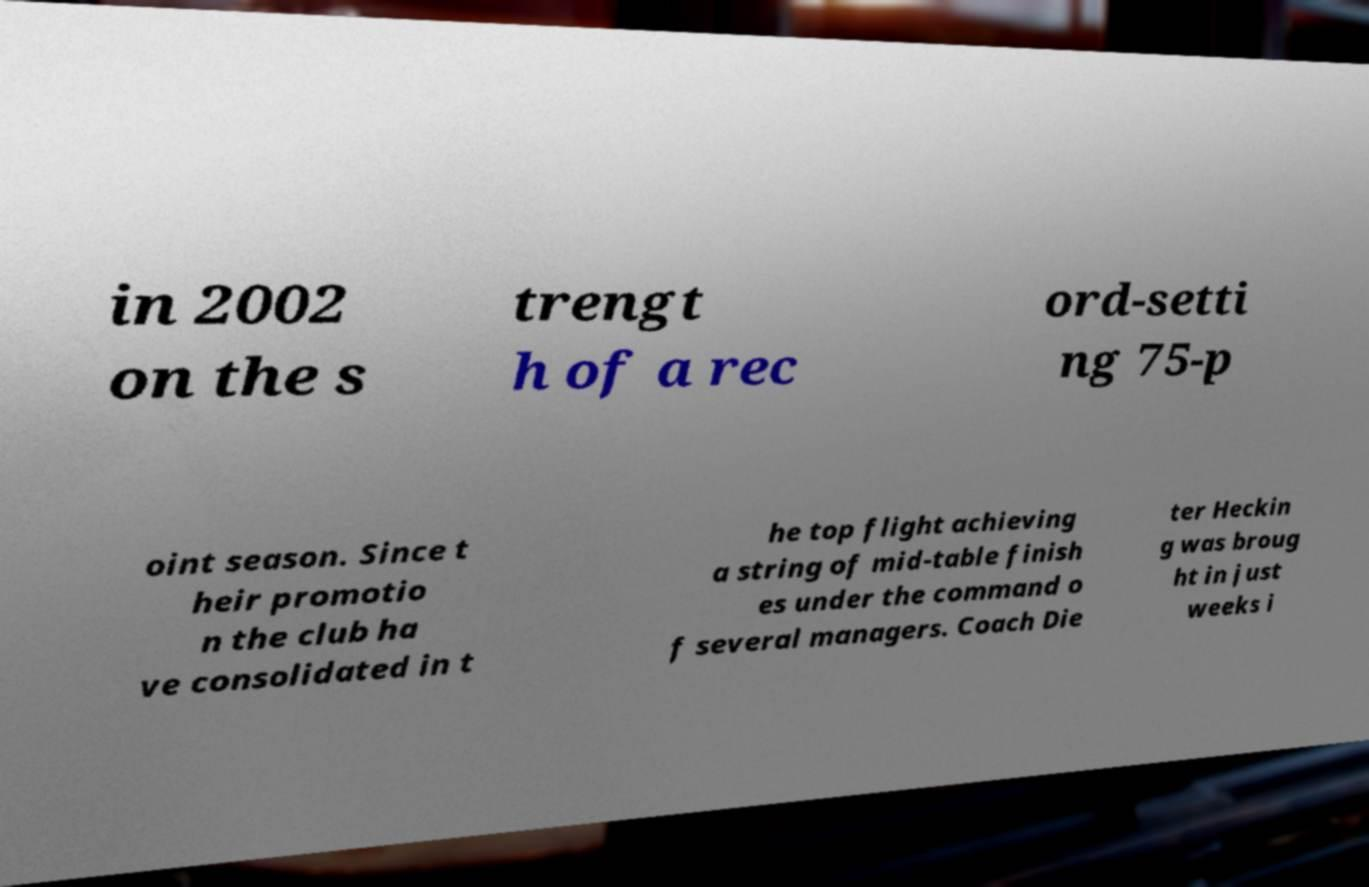What messages or text are displayed in this image? I need them in a readable, typed format. in 2002 on the s trengt h of a rec ord-setti ng 75-p oint season. Since t heir promotio n the club ha ve consolidated in t he top flight achieving a string of mid-table finish es under the command o f several managers. Coach Die ter Heckin g was broug ht in just weeks i 